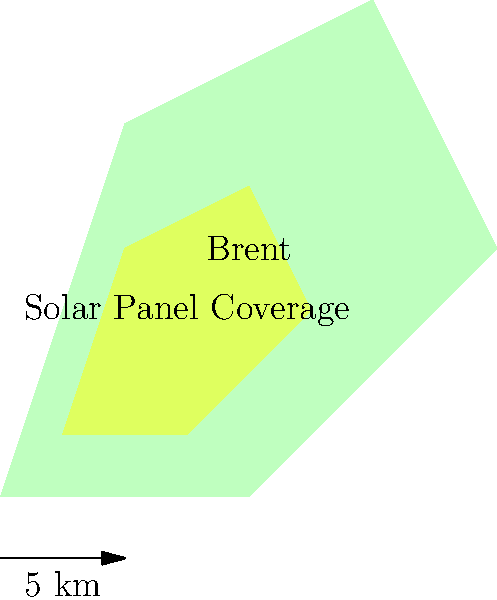Based on the map overlay of solar panel coverage in Brent, approximately what percentage of the borough's rooftops appear to have solar panels installed? To estimate the percentage of rooftops with solar panels in Brent, we need to follow these steps:

1. Observe the map overlay, which shows the borough of Brent in light green and the solar panel coverage in yellow.

2. Estimate the total area of Brent by visually dividing the map into sections.

3. Estimate the area covered by solar panels (yellow overlay) using the same visual sectioning method.

4. Calculate the ratio of solar panel coverage to total area:

   Let's assume the total area of Brent can be divided into approximately 20 equal sections.
   The solar panel coverage appears to occupy about 5 of these sections.

5. Convert the ratio to a percentage:
   
   $\frac{5}{20} = 0.25$
   $0.25 \times 100\% = 25\%$

Therefore, based on this visual estimation, approximately 25% of Brent's rooftops appear to have solar panels installed.

Note: This is a rough estimation based on the provided map overlay. Actual percentages may vary and would require more precise measurement tools and data.
Answer: Approximately 25% 